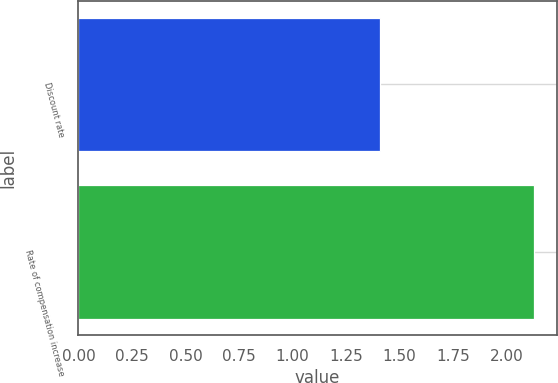<chart> <loc_0><loc_0><loc_500><loc_500><bar_chart><fcel>Discount rate<fcel>Rate of compensation increase<nl><fcel>1.41<fcel>2.13<nl></chart> 